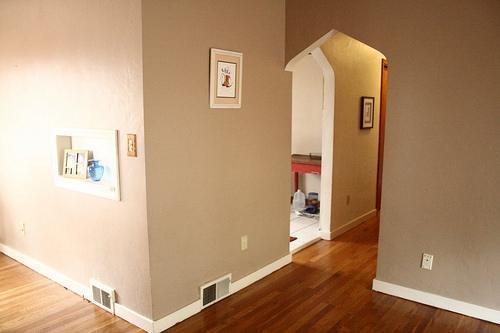How many people are wearing black shirt?
Give a very brief answer. 0. 